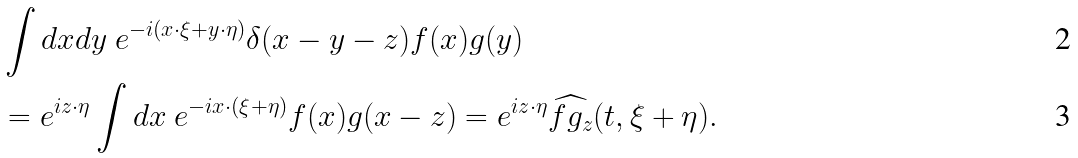Convert formula to latex. <formula><loc_0><loc_0><loc_500><loc_500>& \int d x d y \ e ^ { - i ( x \cdot \xi + y \cdot \eta ) } \delta ( x - y - z ) f ( x ) g ( y ) \\ & = e ^ { i z \cdot \eta } \int d x \ e ^ { - i x \cdot ( \xi + \eta ) } f ( x ) g ( x - z ) = e ^ { i z \cdot \eta } \widehat { f g _ { z } } ( t , \xi + \eta ) .</formula> 